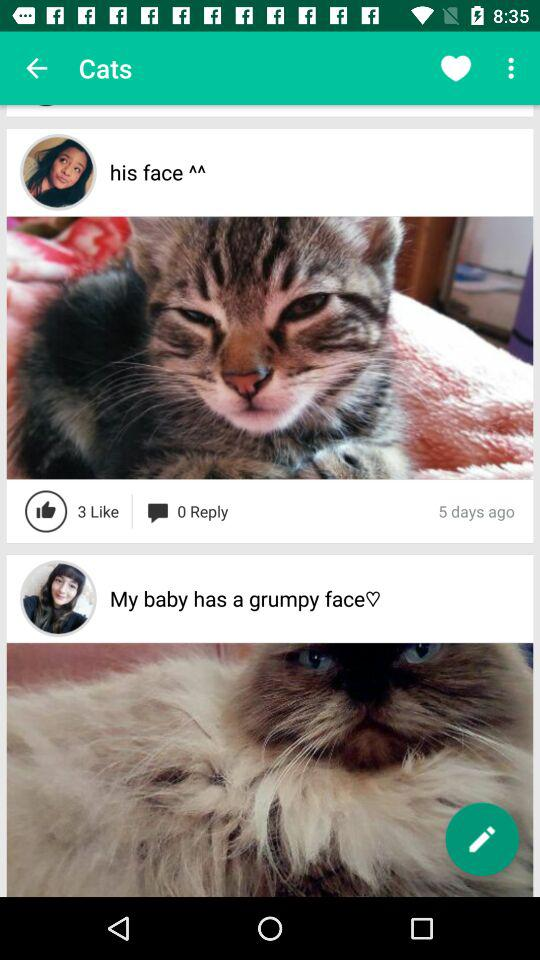How many days ago did "his face" posted the post? "His face" posted the post 5 days ago. 